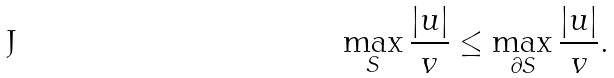<formula> <loc_0><loc_0><loc_500><loc_500>\max _ { S } \frac { | u | } v \leq \max _ { \partial S } \frac { | u | } v .</formula> 